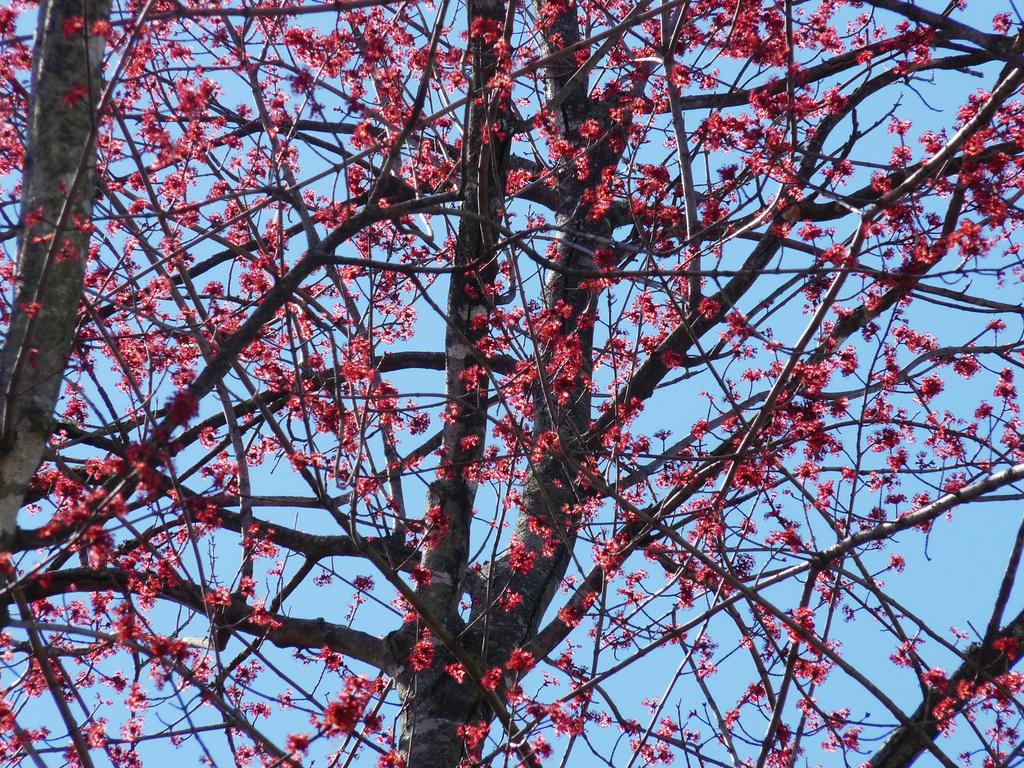What is the main subject in the image? There is a tree in the image. What is special about the tree's appearance? The tree has red color flowers. What can be seen in the background of the image? There is sky visible in the background of the image. What type of calculator can be seen on the tree in the image? There is no calculator present on the tree in the image. What is the value of the quarter depicted on the tree in the image? There is no quarter present on the tree in the image. 